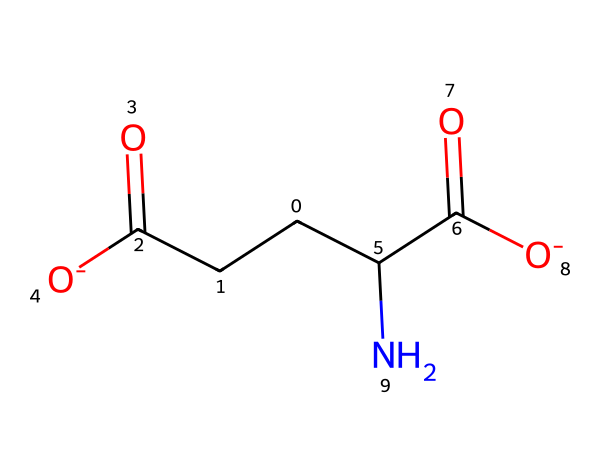What is the molecular formula of this chemical? By analyzing the SMILES representation, we can count the number of each type of atom present. In the structure, we see 5 carbons (C), 9 hydrogens (H), 2 oxygens (O), and 1 nitrogen (N), thus giving us the molecular formula C5H9N2O4.
Answer: C5H9N2O4 How many chiral centers are present in this structure? Looking at the structure derived from the SMILES, we identify the carbon atoms and check for any carbon attached to four different substituents. Here, we find one chiral center at the carbon attached to the amino group.
Answer: 1 What is the role of glutamate in synaptic plasticity? Glutamate functions as an excitatory neurotransmitter that plays a crucial role in synaptic plasticity, especially in long-term potentiation, which is vital for learning and memory processes.
Answer: excitatory neurotransmitter How many double bonds are present in this molecule? In the structure, we need to check for double bonds. The SMILES representation clearly shows two carbonyl groups (C=O), indicating the presence of two double bonds.
Answer: 2 What type of functional groups can be identified in glutamate? The structure contains a carboxyl group (-COOH) and an amino group (-NH2). The presence of these groups classifies glutamate as an amino acid with acidic properties.
Answer: carboxyl and amino groups What is the significance of the negatively charged carboxylate group in glutamate? The negatively charged carboxylate group (due to deprotonation) is important for neurotransmitter function, as it increases the solubility of glutamate in cellular environments and facilitates receptor binding.
Answer: increases solubility and facilitates binding 